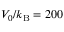<formula> <loc_0><loc_0><loc_500><loc_500>V _ { 0 } / k _ { B } = 2 0 0</formula> 